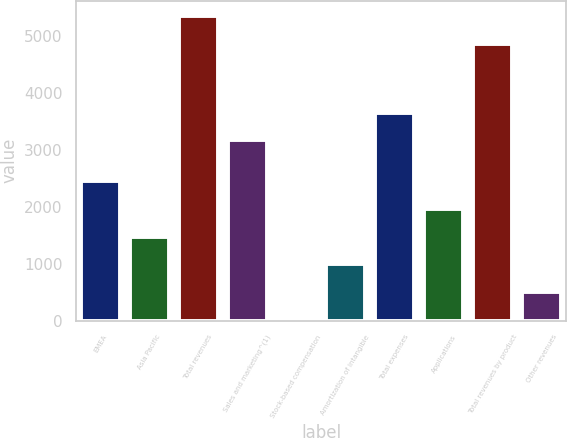<chart> <loc_0><loc_0><loc_500><loc_500><bar_chart><fcel>EMEA<fcel>Asia Pacific<fcel>Total revenues<fcel>Sales and marketing^(1)<fcel>Stock-based compensation<fcel>Amortization of intangible<fcel>Total expenses<fcel>Applications<fcel>Total revenues by product<fcel>Other revenues<nl><fcel>2456.5<fcel>1477.1<fcel>5358.7<fcel>3169<fcel>8<fcel>987.4<fcel>3658.7<fcel>1966.8<fcel>4869<fcel>497.7<nl></chart> 